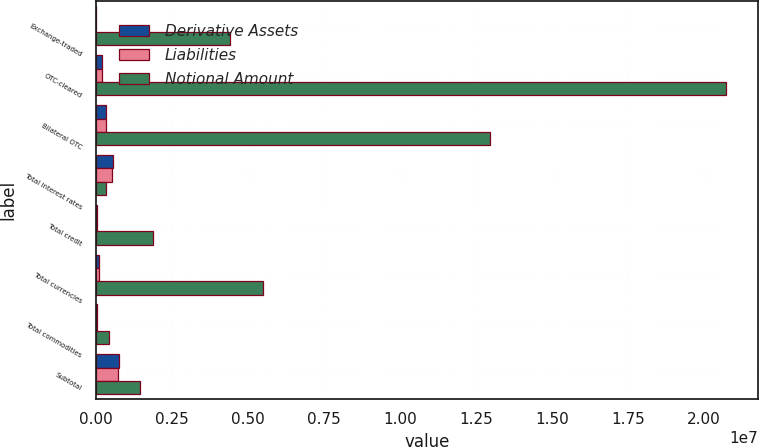Convert chart to OTSL. <chart><loc_0><loc_0><loc_500><loc_500><stacked_bar_chart><ecel><fcel>Exchange-traded<fcel>OTC-cleared<fcel>Bilateral OTC<fcel>Total interest rates<fcel>Total credit<fcel>Total currencies<fcel>Total commodities<fcel>Subtotal<nl><fcel>Derivative Assets<fcel>310<fcel>211272<fcel>345516<fcel>557098<fcel>40882<fcel>97008<fcel>20674<fcel>762822<nl><fcel>Liabilities<fcel>280<fcel>192401<fcel>321458<fcel>514139<fcel>36775<fcel>99567<fcel>21071<fcel>717750<nl><fcel>Notional Amount<fcel>4.40284e+06<fcel>2.07387e+07<fcel>1.29538e+07<fcel>345516<fcel>1.89205e+06<fcel>5.48963e+06<fcel>437054<fcel>1.4555e+06<nl></chart> 